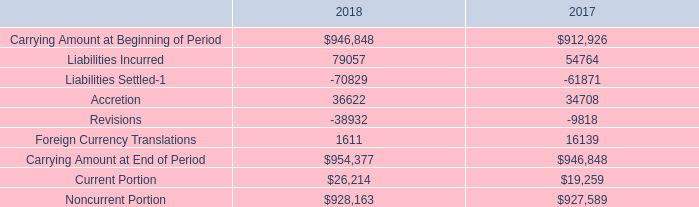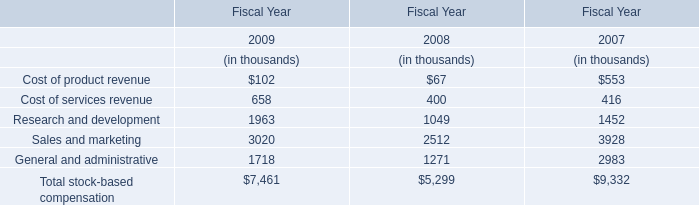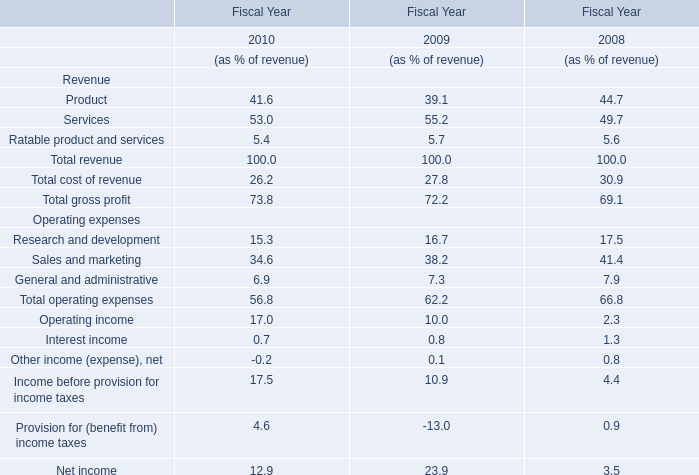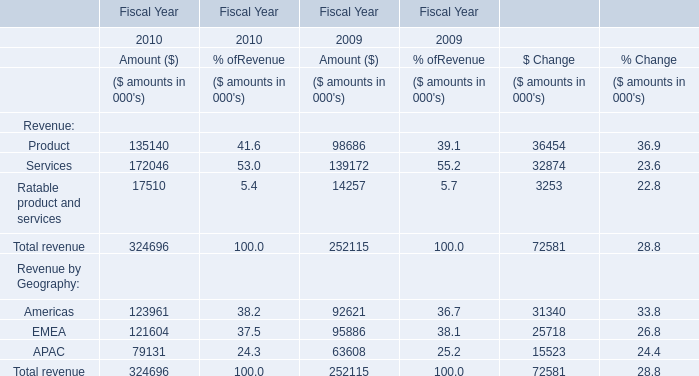what is the percentage of the carrying amount of proved oil and gas properties concerning the total carrying amount in 2017? 
Computations: (370 / (912926 / 1000))
Answer: 0.40529. 